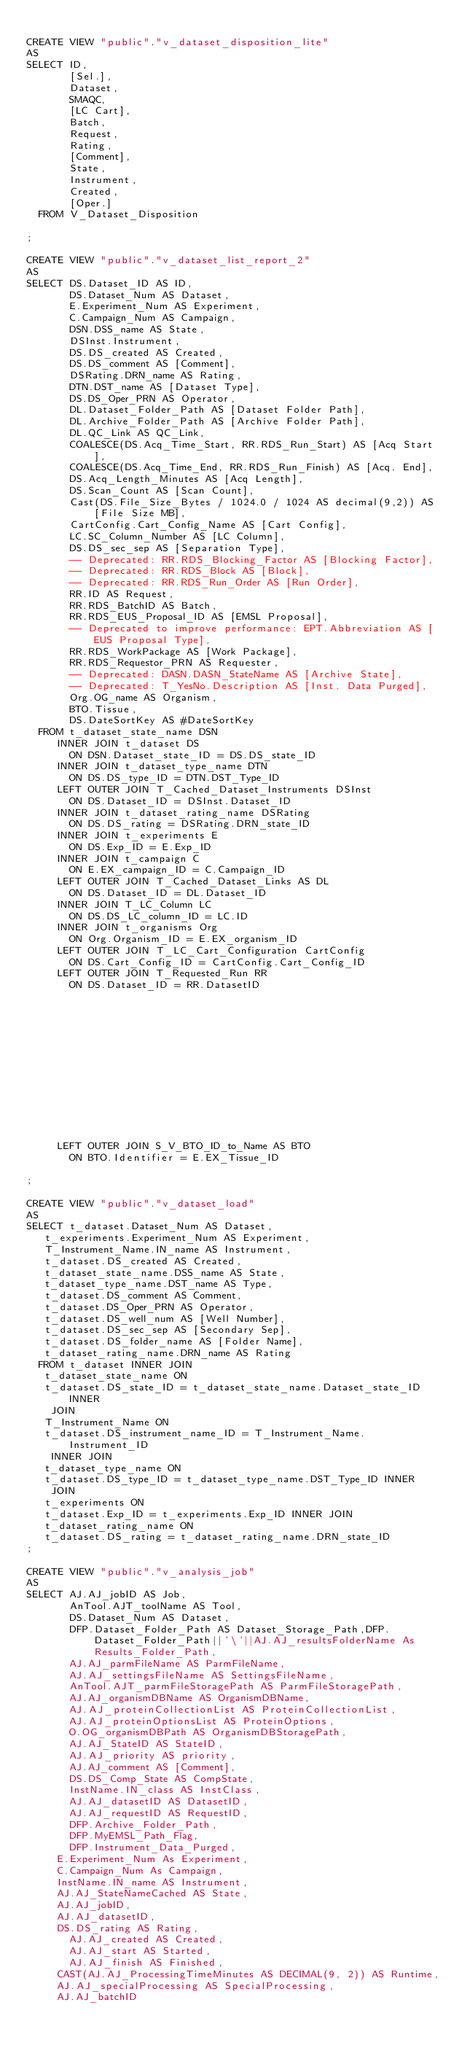Convert code to text. <code><loc_0><loc_0><loc_500><loc_500><_SQL_>
CREATE VIEW "public"."v_dataset_disposition_lite"
AS
SELECT ID,
       [Sel.],
       Dataset,
       SMAQC,
       [LC Cart],
       Batch,
       Request,
       Rating,
       [Comment],
       State,
       Instrument,
       Created,
       [Oper.]
	FROM V_Dataset_Disposition

;

CREATE VIEW "public"."v_dataset_list_report_2"
AS
SELECT DS.Dataset_ID AS ID,
       DS.Dataset_Num AS Dataset,
       E.Experiment_Num AS Experiment,
       C.Campaign_Num AS Campaign,
       DSN.DSS_name AS State,
       DSInst.Instrument,
       DS.DS_created AS Created,
       DS.DS_comment AS [Comment],
       DSRating.DRN_name AS Rating,
       DTN.DST_name AS [Dataset Type],
       DS.DS_Oper_PRN AS Operator,
       DL.Dataset_Folder_Path AS [Dataset Folder Path],
       DL.Archive_Folder_Path AS [Archive Folder Path],
       DL.QC_Link AS QC_Link,
       COALESCE(DS.Acq_Time_Start, RR.RDS_Run_Start) AS [Acq Start],
       COALESCE(DS.Acq_Time_End, RR.RDS_Run_Finish) AS [Acq. End],
       DS.Acq_Length_Minutes AS [Acq Length],
       DS.Scan_Count AS [Scan Count],
       Cast(DS.File_Size_Bytes / 1024.0 / 1024 AS decimal(9,2)) AS [File Size MB],
       CartConfig.Cart_Config_Name AS [Cart Config],
       LC.SC_Column_Number AS [LC Column],
       DS.DS_sec_sep AS [Separation Type],
       -- Deprecated: RR.RDS_Blocking_Factor AS [Blocking Factor],
       -- Deprecated: RR.RDS_Block AS [Block],
       -- Deprecated: RR.RDS_Run_Order AS [Run Order],
       RR.ID AS Request,
       RR.RDS_BatchID AS Batch,
       RR.RDS_EUS_Proposal_ID AS [EMSL Proposal],
       -- Deprecated to improve performance: EPT.Abbreviation AS [EUS Proposal Type],
       RR.RDS_WorkPackage AS [Work Package],
       RR.RDS_Requestor_PRN AS Requester,
       -- Deprecated: DASN.DASN_StateName AS [Archive State],
       -- Deprecated: T_YesNo.Description AS [Inst. Data Purged],
       Org.OG_name AS Organism,
       BTO.Tissue,
       DS.DateSortKey AS #DateSortKey
	FROM t_dataset_state_name DSN
     INNER JOIN t_dataset DS
       ON DSN.Dataset_state_ID = DS.DS_state_ID
     INNER JOIN t_dataset_type_name DTN
       ON DS.DS_type_ID = DTN.DST_Type_ID
     LEFT OUTER JOIN T_Cached_Dataset_Instruments DSInst
       ON DS.Dataset_ID = DSInst.Dataset_ID
     INNER JOIN t_dataset_rating_name DSRating
       ON DS.DS_rating = DSRating.DRN_state_ID
     INNER JOIN t_experiments E
       ON DS.Exp_ID = E.Exp_ID
     INNER JOIN t_campaign C
       ON E.EX_campaign_ID = C.Campaign_ID
     LEFT OUTER JOIN T_Cached_Dataset_Links AS DL
       ON DS.Dataset_ID = DL.Dataset_ID
     INNER JOIN T_LC_Column LC
       ON DS.DS_LC_column_ID = LC.ID
     INNER JOIN t_organisms Org
       ON Org.Organism_ID = E.EX_organism_ID
     LEFT OUTER JOIN T_LC_Cart_Configuration CartConfig
       ON DS.Cart_Config_ID = CartConfig.Cart_Config_ID
     LEFT OUTER JOIN T_Requested_Run RR
       ON DS.Dataset_ID = RR.DatasetID













     LEFT OUTER JOIN S_V_BTO_ID_to_Name AS BTO
       ON BTO.Identifier = E.EX_Tissue_ID

;

CREATE VIEW "public"."v_dataset_load"
AS
SELECT t_dataset.Dataset_Num AS Dataset,
   t_experiments.Experiment_Num AS Experiment,
   T_Instrument_Name.IN_name AS Instrument,
   t_dataset.DS_created AS Created,
   t_dataset_state_name.DSS_name AS State,
   t_dataset_type_name.DST_name AS Type,
   t_dataset.DS_comment AS Comment,
   t_dataset.DS_Oper_PRN AS Operator,
   t_dataset.DS_well_num AS [Well Number],
   t_dataset.DS_sec_sep AS [Secondary Sep],
   t_dataset.DS_folder_name AS [Folder Name],
   t_dataset_rating_name.DRN_name AS Rating
	FROM t_dataset INNER JOIN
   t_dataset_state_name ON
   t_dataset.DS_state_ID = t_dataset_state_name.Dataset_state_ID INNER
    JOIN
   T_Instrument_Name ON
   t_dataset.DS_instrument_name_ID = T_Instrument_Name.Instrument_ID
    INNER JOIN
   t_dataset_type_name ON
   t_dataset.DS_type_ID = t_dataset_type_name.DST_Type_ID INNER
    JOIN
   t_experiments ON
   t_dataset.Exp_ID = t_experiments.Exp_ID INNER JOIN
   t_dataset_rating_name ON
   t_dataset.DS_rating = t_dataset_rating_name.DRN_state_ID
;

CREATE VIEW "public"."v_analysis_job"
AS
SELECT AJ.AJ_jobID AS Job,
       AnTool.AJT_toolName AS Tool,
       DS.Dataset_Num AS Dataset,
       DFP.Dataset_Folder_Path AS Dataset_Storage_Path,DFP.Dataset_Folder_Path||'\'||AJ.AJ_resultsFolderName As Results_Folder_Path,
       AJ.AJ_parmFileName AS ParmFileName,
       AJ.AJ_settingsFileName AS SettingsFileName,
       AnTool.AJT_parmFileStoragePath AS ParmFileStoragePath,
       AJ.AJ_organismDBName AS OrganismDBName,
       AJ.AJ_proteinCollectionList AS ProteinCollectionList,
       AJ.AJ_proteinOptionsList AS ProteinOptions,
       O.OG_organismDBPath AS OrganismDBStoragePath,
       AJ.AJ_StateID AS StateID,
       AJ.AJ_priority AS priority,
       AJ.AJ_comment AS [Comment],
       DS.DS_Comp_State AS CompState,
       InstName.IN_class AS InstClass,
       AJ.AJ_datasetID AS DatasetID,
       AJ.AJ_requestID AS RequestID,
       DFP.Archive_Folder_Path,
       DFP.MyEMSL_Path_Flag,
       DFP.Instrument_Data_Purged,
	   E.Experiment_Num As Experiment,
	   C.Campaign_Num As Campaign,
	   InstName.IN_name AS Instrument,
	   AJ.AJ_StateNameCached AS State,
	   AJ.AJ_jobID,
	   AJ.AJ_datasetID,
	   DS.DS_rating AS Rating,
       AJ.AJ_created AS Created,
       AJ.AJ_start AS Started,
       AJ.AJ_finish AS Finished,
	   CAST(AJ.AJ_ProcessingTimeMinutes AS DECIMAL(9, 2)) AS Runtime,
	   AJ.AJ_specialProcessing AS SpecialProcessing,
	   AJ.AJ_batchID</code> 